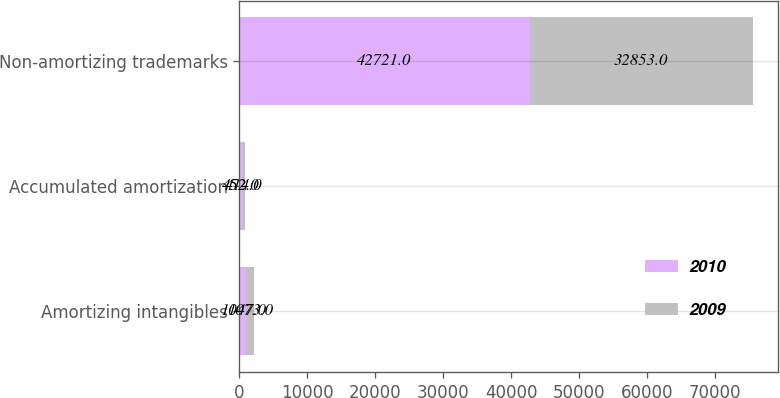Convert chart to OTSL. <chart><loc_0><loc_0><loc_500><loc_500><stacked_bar_chart><ecel><fcel>Amortizing intangibles<fcel>Accumulated amortization<fcel>Non-amortizing trademarks<nl><fcel>2010<fcel>1047<fcel>452<fcel>42721<nl><fcel>2009<fcel>1073<fcel>414<fcel>32853<nl></chart> 